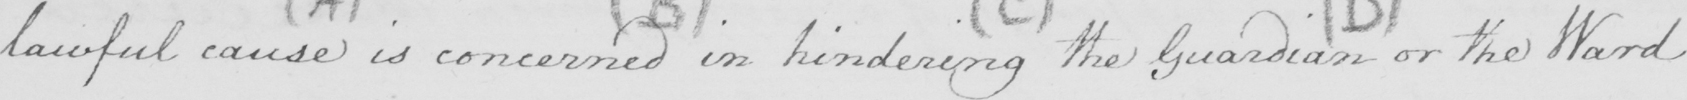What is written in this line of handwriting? lawful cause is concerned in hindering the Guardian or the Ward 